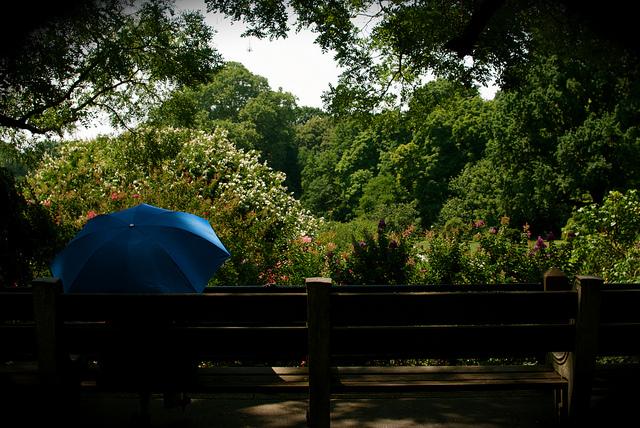Is it raining?
Keep it brief. No. What season is present?
Concise answer only. Spring. What is the pattern on the umbrella?
Give a very brief answer. Solid. Is he doing a trick?
Concise answer only. No. What is the blue object?
Be succinct. Umbrella. What type of park is this?
Be succinct. National. Is someone on the bench?
Write a very short answer. Yes. Is the bench occupied?
Concise answer only. Yes. What color are the umbrellas?
Be succinct. Blue. What time of the year is this picture taken in?
Be succinct. Spring. What are the people on the bench looking at?
Concise answer only. Trees. 